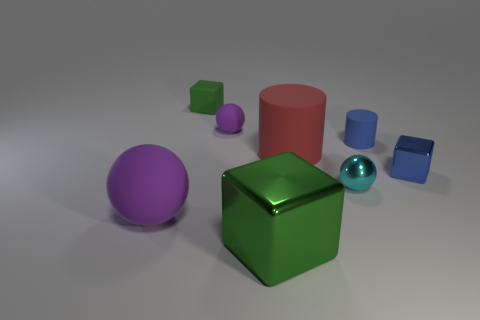Subtract all gray cylinders. How many purple balls are left? 2 Subtract all rubber blocks. How many blocks are left? 2 Add 1 small gray metallic cubes. How many objects exist? 9 Subtract all blocks. How many objects are left? 5 Subtract all tiny purple rubber objects. Subtract all large green rubber balls. How many objects are left? 7 Add 1 small blue metal objects. How many small blue metal objects are left? 2 Add 3 big balls. How many big balls exist? 4 Subtract 0 purple cubes. How many objects are left? 8 